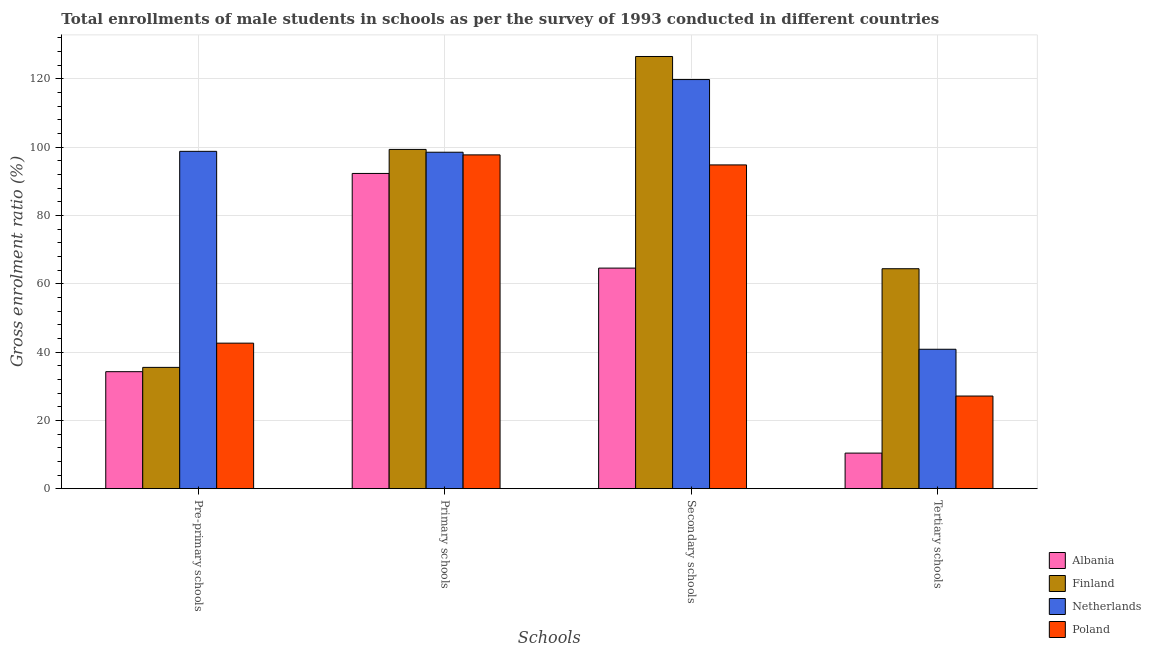How many different coloured bars are there?
Your response must be concise. 4. How many bars are there on the 4th tick from the left?
Your answer should be very brief. 4. What is the label of the 2nd group of bars from the left?
Keep it short and to the point. Primary schools. What is the gross enrolment ratio(male) in tertiary schools in Finland?
Your answer should be compact. 64.39. Across all countries, what is the maximum gross enrolment ratio(male) in pre-primary schools?
Offer a terse response. 98.75. Across all countries, what is the minimum gross enrolment ratio(male) in pre-primary schools?
Your response must be concise. 34.25. In which country was the gross enrolment ratio(male) in pre-primary schools maximum?
Your response must be concise. Netherlands. In which country was the gross enrolment ratio(male) in pre-primary schools minimum?
Make the answer very short. Albania. What is the total gross enrolment ratio(male) in tertiary schools in the graph?
Offer a terse response. 142.73. What is the difference between the gross enrolment ratio(male) in primary schools in Netherlands and that in Finland?
Provide a short and direct response. -0.82. What is the difference between the gross enrolment ratio(male) in primary schools in Albania and the gross enrolment ratio(male) in tertiary schools in Finland?
Provide a succinct answer. 27.89. What is the average gross enrolment ratio(male) in tertiary schools per country?
Offer a terse response. 35.68. What is the difference between the gross enrolment ratio(male) in primary schools and gross enrolment ratio(male) in tertiary schools in Finland?
Ensure brevity in your answer.  34.93. In how many countries, is the gross enrolment ratio(male) in pre-primary schools greater than 64 %?
Your answer should be very brief. 1. What is the ratio of the gross enrolment ratio(male) in tertiary schools in Poland to that in Netherlands?
Your answer should be compact. 0.66. Is the gross enrolment ratio(male) in secondary schools in Albania less than that in Poland?
Your answer should be compact. Yes. Is the difference between the gross enrolment ratio(male) in tertiary schools in Netherlands and Poland greater than the difference between the gross enrolment ratio(male) in pre-primary schools in Netherlands and Poland?
Keep it short and to the point. No. What is the difference between the highest and the second highest gross enrolment ratio(male) in pre-primary schools?
Ensure brevity in your answer.  56.15. What is the difference between the highest and the lowest gross enrolment ratio(male) in secondary schools?
Provide a succinct answer. 61.95. In how many countries, is the gross enrolment ratio(male) in secondary schools greater than the average gross enrolment ratio(male) in secondary schools taken over all countries?
Make the answer very short. 2. Is the sum of the gross enrolment ratio(male) in primary schools in Poland and Netherlands greater than the maximum gross enrolment ratio(male) in pre-primary schools across all countries?
Your answer should be compact. Yes. Is it the case that in every country, the sum of the gross enrolment ratio(male) in primary schools and gross enrolment ratio(male) in secondary schools is greater than the sum of gross enrolment ratio(male) in tertiary schools and gross enrolment ratio(male) in pre-primary schools?
Provide a succinct answer. Yes. What does the 4th bar from the right in Tertiary schools represents?
Give a very brief answer. Albania. Is it the case that in every country, the sum of the gross enrolment ratio(male) in pre-primary schools and gross enrolment ratio(male) in primary schools is greater than the gross enrolment ratio(male) in secondary schools?
Give a very brief answer. Yes. What is the difference between two consecutive major ticks on the Y-axis?
Provide a short and direct response. 20. Does the graph contain any zero values?
Your answer should be very brief. No. How many legend labels are there?
Ensure brevity in your answer.  4. What is the title of the graph?
Make the answer very short. Total enrollments of male students in schools as per the survey of 1993 conducted in different countries. Does "Germany" appear as one of the legend labels in the graph?
Make the answer very short. No. What is the label or title of the X-axis?
Your response must be concise. Schools. What is the label or title of the Y-axis?
Keep it short and to the point. Gross enrolment ratio (%). What is the Gross enrolment ratio (%) of Albania in Pre-primary schools?
Offer a very short reply. 34.25. What is the Gross enrolment ratio (%) of Finland in Pre-primary schools?
Keep it short and to the point. 35.51. What is the Gross enrolment ratio (%) of Netherlands in Pre-primary schools?
Keep it short and to the point. 98.75. What is the Gross enrolment ratio (%) in Poland in Pre-primary schools?
Provide a succinct answer. 42.6. What is the Gross enrolment ratio (%) of Albania in Primary schools?
Your response must be concise. 92.28. What is the Gross enrolment ratio (%) of Finland in Primary schools?
Your answer should be very brief. 99.31. What is the Gross enrolment ratio (%) of Netherlands in Primary schools?
Your response must be concise. 98.49. What is the Gross enrolment ratio (%) of Poland in Primary schools?
Make the answer very short. 97.71. What is the Gross enrolment ratio (%) in Albania in Secondary schools?
Provide a succinct answer. 64.57. What is the Gross enrolment ratio (%) in Finland in Secondary schools?
Give a very brief answer. 126.52. What is the Gross enrolment ratio (%) of Netherlands in Secondary schools?
Offer a very short reply. 119.76. What is the Gross enrolment ratio (%) in Poland in Secondary schools?
Offer a terse response. 94.78. What is the Gross enrolment ratio (%) of Albania in Tertiary schools?
Give a very brief answer. 10.41. What is the Gross enrolment ratio (%) in Finland in Tertiary schools?
Make the answer very short. 64.39. What is the Gross enrolment ratio (%) of Netherlands in Tertiary schools?
Your answer should be very brief. 40.81. What is the Gross enrolment ratio (%) of Poland in Tertiary schools?
Offer a terse response. 27.12. Across all Schools, what is the maximum Gross enrolment ratio (%) of Albania?
Make the answer very short. 92.28. Across all Schools, what is the maximum Gross enrolment ratio (%) in Finland?
Make the answer very short. 126.52. Across all Schools, what is the maximum Gross enrolment ratio (%) in Netherlands?
Ensure brevity in your answer.  119.76. Across all Schools, what is the maximum Gross enrolment ratio (%) of Poland?
Make the answer very short. 97.71. Across all Schools, what is the minimum Gross enrolment ratio (%) of Albania?
Provide a short and direct response. 10.41. Across all Schools, what is the minimum Gross enrolment ratio (%) in Finland?
Provide a short and direct response. 35.51. Across all Schools, what is the minimum Gross enrolment ratio (%) of Netherlands?
Provide a succinct answer. 40.81. Across all Schools, what is the minimum Gross enrolment ratio (%) of Poland?
Ensure brevity in your answer.  27.12. What is the total Gross enrolment ratio (%) in Albania in the graph?
Make the answer very short. 201.51. What is the total Gross enrolment ratio (%) in Finland in the graph?
Your response must be concise. 325.73. What is the total Gross enrolment ratio (%) in Netherlands in the graph?
Your response must be concise. 357.82. What is the total Gross enrolment ratio (%) in Poland in the graph?
Offer a terse response. 262.21. What is the difference between the Gross enrolment ratio (%) of Albania in Pre-primary schools and that in Primary schools?
Your answer should be compact. -58.03. What is the difference between the Gross enrolment ratio (%) in Finland in Pre-primary schools and that in Primary schools?
Offer a very short reply. -63.81. What is the difference between the Gross enrolment ratio (%) of Netherlands in Pre-primary schools and that in Primary schools?
Offer a terse response. 0.26. What is the difference between the Gross enrolment ratio (%) in Poland in Pre-primary schools and that in Primary schools?
Your response must be concise. -55.11. What is the difference between the Gross enrolment ratio (%) in Albania in Pre-primary schools and that in Secondary schools?
Your answer should be very brief. -30.32. What is the difference between the Gross enrolment ratio (%) of Finland in Pre-primary schools and that in Secondary schools?
Your answer should be compact. -91.01. What is the difference between the Gross enrolment ratio (%) of Netherlands in Pre-primary schools and that in Secondary schools?
Offer a very short reply. -21.01. What is the difference between the Gross enrolment ratio (%) of Poland in Pre-primary schools and that in Secondary schools?
Your answer should be compact. -52.18. What is the difference between the Gross enrolment ratio (%) in Albania in Pre-primary schools and that in Tertiary schools?
Ensure brevity in your answer.  23.84. What is the difference between the Gross enrolment ratio (%) of Finland in Pre-primary schools and that in Tertiary schools?
Make the answer very short. -28.88. What is the difference between the Gross enrolment ratio (%) of Netherlands in Pre-primary schools and that in Tertiary schools?
Provide a succinct answer. 57.94. What is the difference between the Gross enrolment ratio (%) of Poland in Pre-primary schools and that in Tertiary schools?
Provide a short and direct response. 15.48. What is the difference between the Gross enrolment ratio (%) of Albania in Primary schools and that in Secondary schools?
Your answer should be compact. 27.71. What is the difference between the Gross enrolment ratio (%) in Finland in Primary schools and that in Secondary schools?
Your answer should be very brief. -27.2. What is the difference between the Gross enrolment ratio (%) in Netherlands in Primary schools and that in Secondary schools?
Your answer should be compact. -21.27. What is the difference between the Gross enrolment ratio (%) of Poland in Primary schools and that in Secondary schools?
Your answer should be compact. 2.94. What is the difference between the Gross enrolment ratio (%) of Albania in Primary schools and that in Tertiary schools?
Your response must be concise. 81.87. What is the difference between the Gross enrolment ratio (%) in Finland in Primary schools and that in Tertiary schools?
Offer a very short reply. 34.93. What is the difference between the Gross enrolment ratio (%) in Netherlands in Primary schools and that in Tertiary schools?
Your response must be concise. 57.68. What is the difference between the Gross enrolment ratio (%) of Poland in Primary schools and that in Tertiary schools?
Provide a short and direct response. 70.59. What is the difference between the Gross enrolment ratio (%) of Albania in Secondary schools and that in Tertiary schools?
Keep it short and to the point. 54.16. What is the difference between the Gross enrolment ratio (%) in Finland in Secondary schools and that in Tertiary schools?
Ensure brevity in your answer.  62.13. What is the difference between the Gross enrolment ratio (%) in Netherlands in Secondary schools and that in Tertiary schools?
Provide a succinct answer. 78.95. What is the difference between the Gross enrolment ratio (%) of Poland in Secondary schools and that in Tertiary schools?
Your answer should be compact. 67.66. What is the difference between the Gross enrolment ratio (%) in Albania in Pre-primary schools and the Gross enrolment ratio (%) in Finland in Primary schools?
Provide a short and direct response. -65.07. What is the difference between the Gross enrolment ratio (%) in Albania in Pre-primary schools and the Gross enrolment ratio (%) in Netherlands in Primary schools?
Ensure brevity in your answer.  -64.24. What is the difference between the Gross enrolment ratio (%) in Albania in Pre-primary schools and the Gross enrolment ratio (%) in Poland in Primary schools?
Offer a terse response. -63.47. What is the difference between the Gross enrolment ratio (%) in Finland in Pre-primary schools and the Gross enrolment ratio (%) in Netherlands in Primary schools?
Make the answer very short. -62.98. What is the difference between the Gross enrolment ratio (%) of Finland in Pre-primary schools and the Gross enrolment ratio (%) of Poland in Primary schools?
Your answer should be compact. -62.21. What is the difference between the Gross enrolment ratio (%) in Netherlands in Pre-primary schools and the Gross enrolment ratio (%) in Poland in Primary schools?
Provide a succinct answer. 1.04. What is the difference between the Gross enrolment ratio (%) of Albania in Pre-primary schools and the Gross enrolment ratio (%) of Finland in Secondary schools?
Offer a very short reply. -92.27. What is the difference between the Gross enrolment ratio (%) in Albania in Pre-primary schools and the Gross enrolment ratio (%) in Netherlands in Secondary schools?
Provide a succinct answer. -85.52. What is the difference between the Gross enrolment ratio (%) of Albania in Pre-primary schools and the Gross enrolment ratio (%) of Poland in Secondary schools?
Give a very brief answer. -60.53. What is the difference between the Gross enrolment ratio (%) in Finland in Pre-primary schools and the Gross enrolment ratio (%) in Netherlands in Secondary schools?
Provide a succinct answer. -84.26. What is the difference between the Gross enrolment ratio (%) of Finland in Pre-primary schools and the Gross enrolment ratio (%) of Poland in Secondary schools?
Keep it short and to the point. -59.27. What is the difference between the Gross enrolment ratio (%) in Netherlands in Pre-primary schools and the Gross enrolment ratio (%) in Poland in Secondary schools?
Offer a very short reply. 3.97. What is the difference between the Gross enrolment ratio (%) of Albania in Pre-primary schools and the Gross enrolment ratio (%) of Finland in Tertiary schools?
Your answer should be compact. -30.14. What is the difference between the Gross enrolment ratio (%) of Albania in Pre-primary schools and the Gross enrolment ratio (%) of Netherlands in Tertiary schools?
Your answer should be very brief. -6.56. What is the difference between the Gross enrolment ratio (%) in Albania in Pre-primary schools and the Gross enrolment ratio (%) in Poland in Tertiary schools?
Make the answer very short. 7.13. What is the difference between the Gross enrolment ratio (%) of Finland in Pre-primary schools and the Gross enrolment ratio (%) of Netherlands in Tertiary schools?
Keep it short and to the point. -5.3. What is the difference between the Gross enrolment ratio (%) of Finland in Pre-primary schools and the Gross enrolment ratio (%) of Poland in Tertiary schools?
Your response must be concise. 8.39. What is the difference between the Gross enrolment ratio (%) in Netherlands in Pre-primary schools and the Gross enrolment ratio (%) in Poland in Tertiary schools?
Offer a very short reply. 71.63. What is the difference between the Gross enrolment ratio (%) in Albania in Primary schools and the Gross enrolment ratio (%) in Finland in Secondary schools?
Offer a very short reply. -34.24. What is the difference between the Gross enrolment ratio (%) in Albania in Primary schools and the Gross enrolment ratio (%) in Netherlands in Secondary schools?
Provide a short and direct response. -27.48. What is the difference between the Gross enrolment ratio (%) of Albania in Primary schools and the Gross enrolment ratio (%) of Poland in Secondary schools?
Keep it short and to the point. -2.5. What is the difference between the Gross enrolment ratio (%) of Finland in Primary schools and the Gross enrolment ratio (%) of Netherlands in Secondary schools?
Make the answer very short. -20.45. What is the difference between the Gross enrolment ratio (%) of Finland in Primary schools and the Gross enrolment ratio (%) of Poland in Secondary schools?
Your response must be concise. 4.54. What is the difference between the Gross enrolment ratio (%) of Netherlands in Primary schools and the Gross enrolment ratio (%) of Poland in Secondary schools?
Provide a succinct answer. 3.71. What is the difference between the Gross enrolment ratio (%) in Albania in Primary schools and the Gross enrolment ratio (%) in Finland in Tertiary schools?
Give a very brief answer. 27.89. What is the difference between the Gross enrolment ratio (%) in Albania in Primary schools and the Gross enrolment ratio (%) in Netherlands in Tertiary schools?
Provide a succinct answer. 51.47. What is the difference between the Gross enrolment ratio (%) in Albania in Primary schools and the Gross enrolment ratio (%) in Poland in Tertiary schools?
Your answer should be very brief. 65.16. What is the difference between the Gross enrolment ratio (%) of Finland in Primary schools and the Gross enrolment ratio (%) of Netherlands in Tertiary schools?
Provide a succinct answer. 58.5. What is the difference between the Gross enrolment ratio (%) of Finland in Primary schools and the Gross enrolment ratio (%) of Poland in Tertiary schools?
Keep it short and to the point. 72.19. What is the difference between the Gross enrolment ratio (%) in Netherlands in Primary schools and the Gross enrolment ratio (%) in Poland in Tertiary schools?
Keep it short and to the point. 71.37. What is the difference between the Gross enrolment ratio (%) of Albania in Secondary schools and the Gross enrolment ratio (%) of Finland in Tertiary schools?
Give a very brief answer. 0.18. What is the difference between the Gross enrolment ratio (%) of Albania in Secondary schools and the Gross enrolment ratio (%) of Netherlands in Tertiary schools?
Offer a terse response. 23.76. What is the difference between the Gross enrolment ratio (%) in Albania in Secondary schools and the Gross enrolment ratio (%) in Poland in Tertiary schools?
Offer a terse response. 37.45. What is the difference between the Gross enrolment ratio (%) in Finland in Secondary schools and the Gross enrolment ratio (%) in Netherlands in Tertiary schools?
Make the answer very short. 85.7. What is the difference between the Gross enrolment ratio (%) of Finland in Secondary schools and the Gross enrolment ratio (%) of Poland in Tertiary schools?
Offer a very short reply. 99.4. What is the difference between the Gross enrolment ratio (%) in Netherlands in Secondary schools and the Gross enrolment ratio (%) in Poland in Tertiary schools?
Offer a very short reply. 92.64. What is the average Gross enrolment ratio (%) in Albania per Schools?
Your response must be concise. 50.38. What is the average Gross enrolment ratio (%) in Finland per Schools?
Your response must be concise. 81.43. What is the average Gross enrolment ratio (%) of Netherlands per Schools?
Your response must be concise. 89.45. What is the average Gross enrolment ratio (%) of Poland per Schools?
Make the answer very short. 65.55. What is the difference between the Gross enrolment ratio (%) in Albania and Gross enrolment ratio (%) in Finland in Pre-primary schools?
Keep it short and to the point. -1.26. What is the difference between the Gross enrolment ratio (%) of Albania and Gross enrolment ratio (%) of Netherlands in Pre-primary schools?
Provide a short and direct response. -64.5. What is the difference between the Gross enrolment ratio (%) in Albania and Gross enrolment ratio (%) in Poland in Pre-primary schools?
Make the answer very short. -8.35. What is the difference between the Gross enrolment ratio (%) in Finland and Gross enrolment ratio (%) in Netherlands in Pre-primary schools?
Provide a short and direct response. -63.24. What is the difference between the Gross enrolment ratio (%) in Finland and Gross enrolment ratio (%) in Poland in Pre-primary schools?
Make the answer very short. -7.09. What is the difference between the Gross enrolment ratio (%) in Netherlands and Gross enrolment ratio (%) in Poland in Pre-primary schools?
Offer a very short reply. 56.15. What is the difference between the Gross enrolment ratio (%) of Albania and Gross enrolment ratio (%) of Finland in Primary schools?
Provide a short and direct response. -7.03. What is the difference between the Gross enrolment ratio (%) of Albania and Gross enrolment ratio (%) of Netherlands in Primary schools?
Offer a very short reply. -6.21. What is the difference between the Gross enrolment ratio (%) in Albania and Gross enrolment ratio (%) in Poland in Primary schools?
Provide a short and direct response. -5.43. What is the difference between the Gross enrolment ratio (%) of Finland and Gross enrolment ratio (%) of Netherlands in Primary schools?
Ensure brevity in your answer.  0.82. What is the difference between the Gross enrolment ratio (%) in Finland and Gross enrolment ratio (%) in Poland in Primary schools?
Provide a short and direct response. 1.6. What is the difference between the Gross enrolment ratio (%) of Netherlands and Gross enrolment ratio (%) of Poland in Primary schools?
Your response must be concise. 0.78. What is the difference between the Gross enrolment ratio (%) of Albania and Gross enrolment ratio (%) of Finland in Secondary schools?
Ensure brevity in your answer.  -61.95. What is the difference between the Gross enrolment ratio (%) in Albania and Gross enrolment ratio (%) in Netherlands in Secondary schools?
Give a very brief answer. -55.19. What is the difference between the Gross enrolment ratio (%) in Albania and Gross enrolment ratio (%) in Poland in Secondary schools?
Your answer should be compact. -30.2. What is the difference between the Gross enrolment ratio (%) of Finland and Gross enrolment ratio (%) of Netherlands in Secondary schools?
Make the answer very short. 6.75. What is the difference between the Gross enrolment ratio (%) in Finland and Gross enrolment ratio (%) in Poland in Secondary schools?
Your answer should be compact. 31.74. What is the difference between the Gross enrolment ratio (%) in Netherlands and Gross enrolment ratio (%) in Poland in Secondary schools?
Provide a short and direct response. 24.99. What is the difference between the Gross enrolment ratio (%) in Albania and Gross enrolment ratio (%) in Finland in Tertiary schools?
Your response must be concise. -53.97. What is the difference between the Gross enrolment ratio (%) of Albania and Gross enrolment ratio (%) of Netherlands in Tertiary schools?
Your answer should be very brief. -30.4. What is the difference between the Gross enrolment ratio (%) of Albania and Gross enrolment ratio (%) of Poland in Tertiary schools?
Your answer should be compact. -16.71. What is the difference between the Gross enrolment ratio (%) of Finland and Gross enrolment ratio (%) of Netherlands in Tertiary schools?
Give a very brief answer. 23.58. What is the difference between the Gross enrolment ratio (%) of Finland and Gross enrolment ratio (%) of Poland in Tertiary schools?
Your response must be concise. 37.27. What is the difference between the Gross enrolment ratio (%) of Netherlands and Gross enrolment ratio (%) of Poland in Tertiary schools?
Your answer should be compact. 13.69. What is the ratio of the Gross enrolment ratio (%) in Albania in Pre-primary schools to that in Primary schools?
Your answer should be very brief. 0.37. What is the ratio of the Gross enrolment ratio (%) of Finland in Pre-primary schools to that in Primary schools?
Keep it short and to the point. 0.36. What is the ratio of the Gross enrolment ratio (%) of Poland in Pre-primary schools to that in Primary schools?
Provide a succinct answer. 0.44. What is the ratio of the Gross enrolment ratio (%) of Albania in Pre-primary schools to that in Secondary schools?
Provide a succinct answer. 0.53. What is the ratio of the Gross enrolment ratio (%) in Finland in Pre-primary schools to that in Secondary schools?
Ensure brevity in your answer.  0.28. What is the ratio of the Gross enrolment ratio (%) in Netherlands in Pre-primary schools to that in Secondary schools?
Give a very brief answer. 0.82. What is the ratio of the Gross enrolment ratio (%) of Poland in Pre-primary schools to that in Secondary schools?
Provide a short and direct response. 0.45. What is the ratio of the Gross enrolment ratio (%) in Albania in Pre-primary schools to that in Tertiary schools?
Provide a short and direct response. 3.29. What is the ratio of the Gross enrolment ratio (%) of Finland in Pre-primary schools to that in Tertiary schools?
Make the answer very short. 0.55. What is the ratio of the Gross enrolment ratio (%) in Netherlands in Pre-primary schools to that in Tertiary schools?
Your answer should be compact. 2.42. What is the ratio of the Gross enrolment ratio (%) in Poland in Pre-primary schools to that in Tertiary schools?
Make the answer very short. 1.57. What is the ratio of the Gross enrolment ratio (%) in Albania in Primary schools to that in Secondary schools?
Offer a very short reply. 1.43. What is the ratio of the Gross enrolment ratio (%) of Finland in Primary schools to that in Secondary schools?
Your response must be concise. 0.79. What is the ratio of the Gross enrolment ratio (%) in Netherlands in Primary schools to that in Secondary schools?
Make the answer very short. 0.82. What is the ratio of the Gross enrolment ratio (%) in Poland in Primary schools to that in Secondary schools?
Ensure brevity in your answer.  1.03. What is the ratio of the Gross enrolment ratio (%) in Albania in Primary schools to that in Tertiary schools?
Provide a short and direct response. 8.86. What is the ratio of the Gross enrolment ratio (%) of Finland in Primary schools to that in Tertiary schools?
Provide a succinct answer. 1.54. What is the ratio of the Gross enrolment ratio (%) of Netherlands in Primary schools to that in Tertiary schools?
Offer a terse response. 2.41. What is the ratio of the Gross enrolment ratio (%) in Poland in Primary schools to that in Tertiary schools?
Keep it short and to the point. 3.6. What is the ratio of the Gross enrolment ratio (%) in Albania in Secondary schools to that in Tertiary schools?
Provide a succinct answer. 6.2. What is the ratio of the Gross enrolment ratio (%) in Finland in Secondary schools to that in Tertiary schools?
Ensure brevity in your answer.  1.96. What is the ratio of the Gross enrolment ratio (%) of Netherlands in Secondary schools to that in Tertiary schools?
Ensure brevity in your answer.  2.93. What is the ratio of the Gross enrolment ratio (%) of Poland in Secondary schools to that in Tertiary schools?
Your answer should be compact. 3.49. What is the difference between the highest and the second highest Gross enrolment ratio (%) of Albania?
Provide a succinct answer. 27.71. What is the difference between the highest and the second highest Gross enrolment ratio (%) in Finland?
Give a very brief answer. 27.2. What is the difference between the highest and the second highest Gross enrolment ratio (%) in Netherlands?
Ensure brevity in your answer.  21.01. What is the difference between the highest and the second highest Gross enrolment ratio (%) of Poland?
Make the answer very short. 2.94. What is the difference between the highest and the lowest Gross enrolment ratio (%) of Albania?
Offer a very short reply. 81.87. What is the difference between the highest and the lowest Gross enrolment ratio (%) in Finland?
Keep it short and to the point. 91.01. What is the difference between the highest and the lowest Gross enrolment ratio (%) in Netherlands?
Provide a short and direct response. 78.95. What is the difference between the highest and the lowest Gross enrolment ratio (%) in Poland?
Keep it short and to the point. 70.59. 